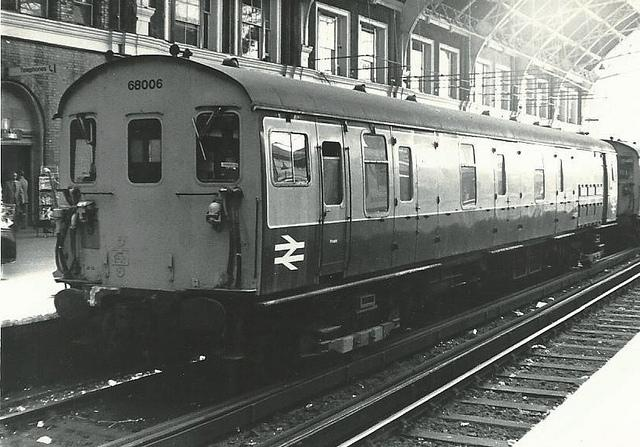What type of building is this? train station 